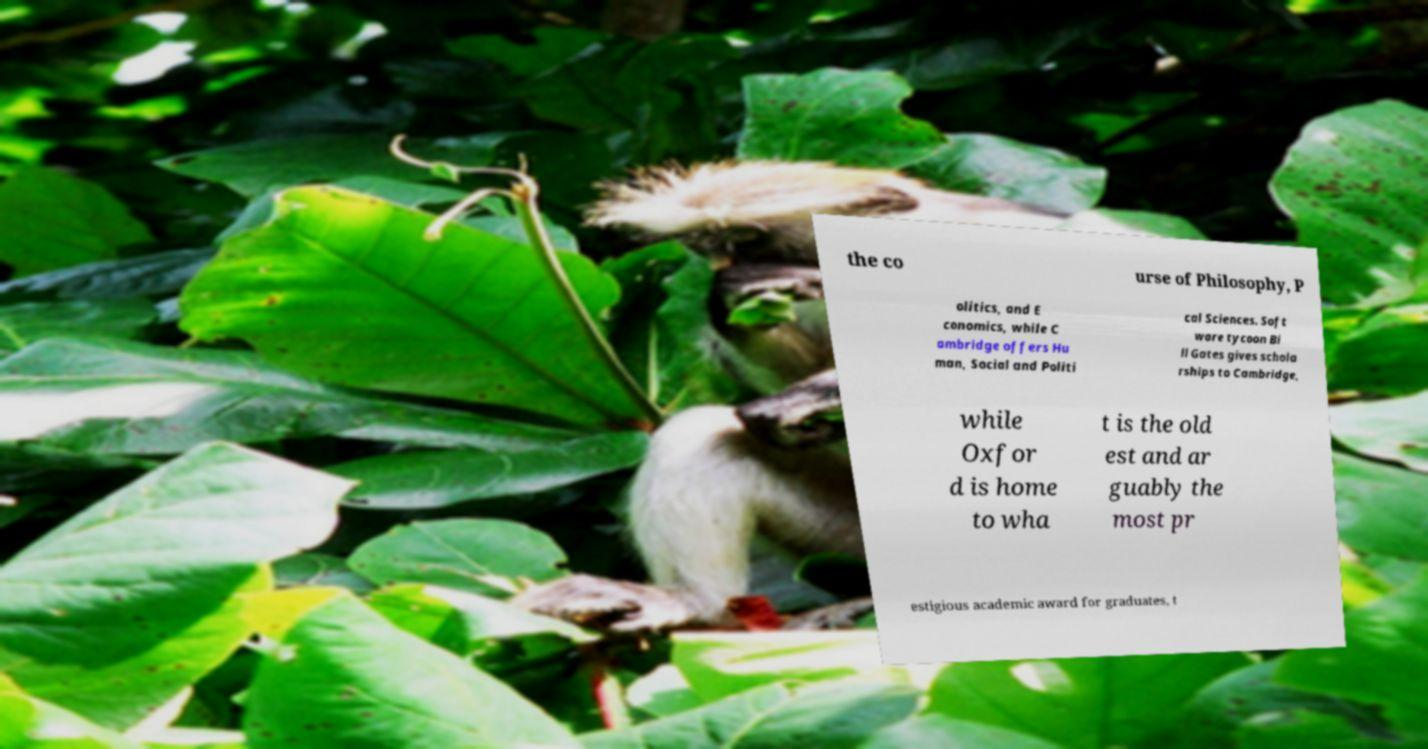What messages or text are displayed in this image? I need them in a readable, typed format. the co urse of Philosophy, P olitics, and E conomics, while C ambridge offers Hu man, Social and Politi cal Sciences. Soft ware tycoon Bi ll Gates gives schola rships to Cambridge, while Oxfor d is home to wha t is the old est and ar guably the most pr estigious academic award for graduates, t 